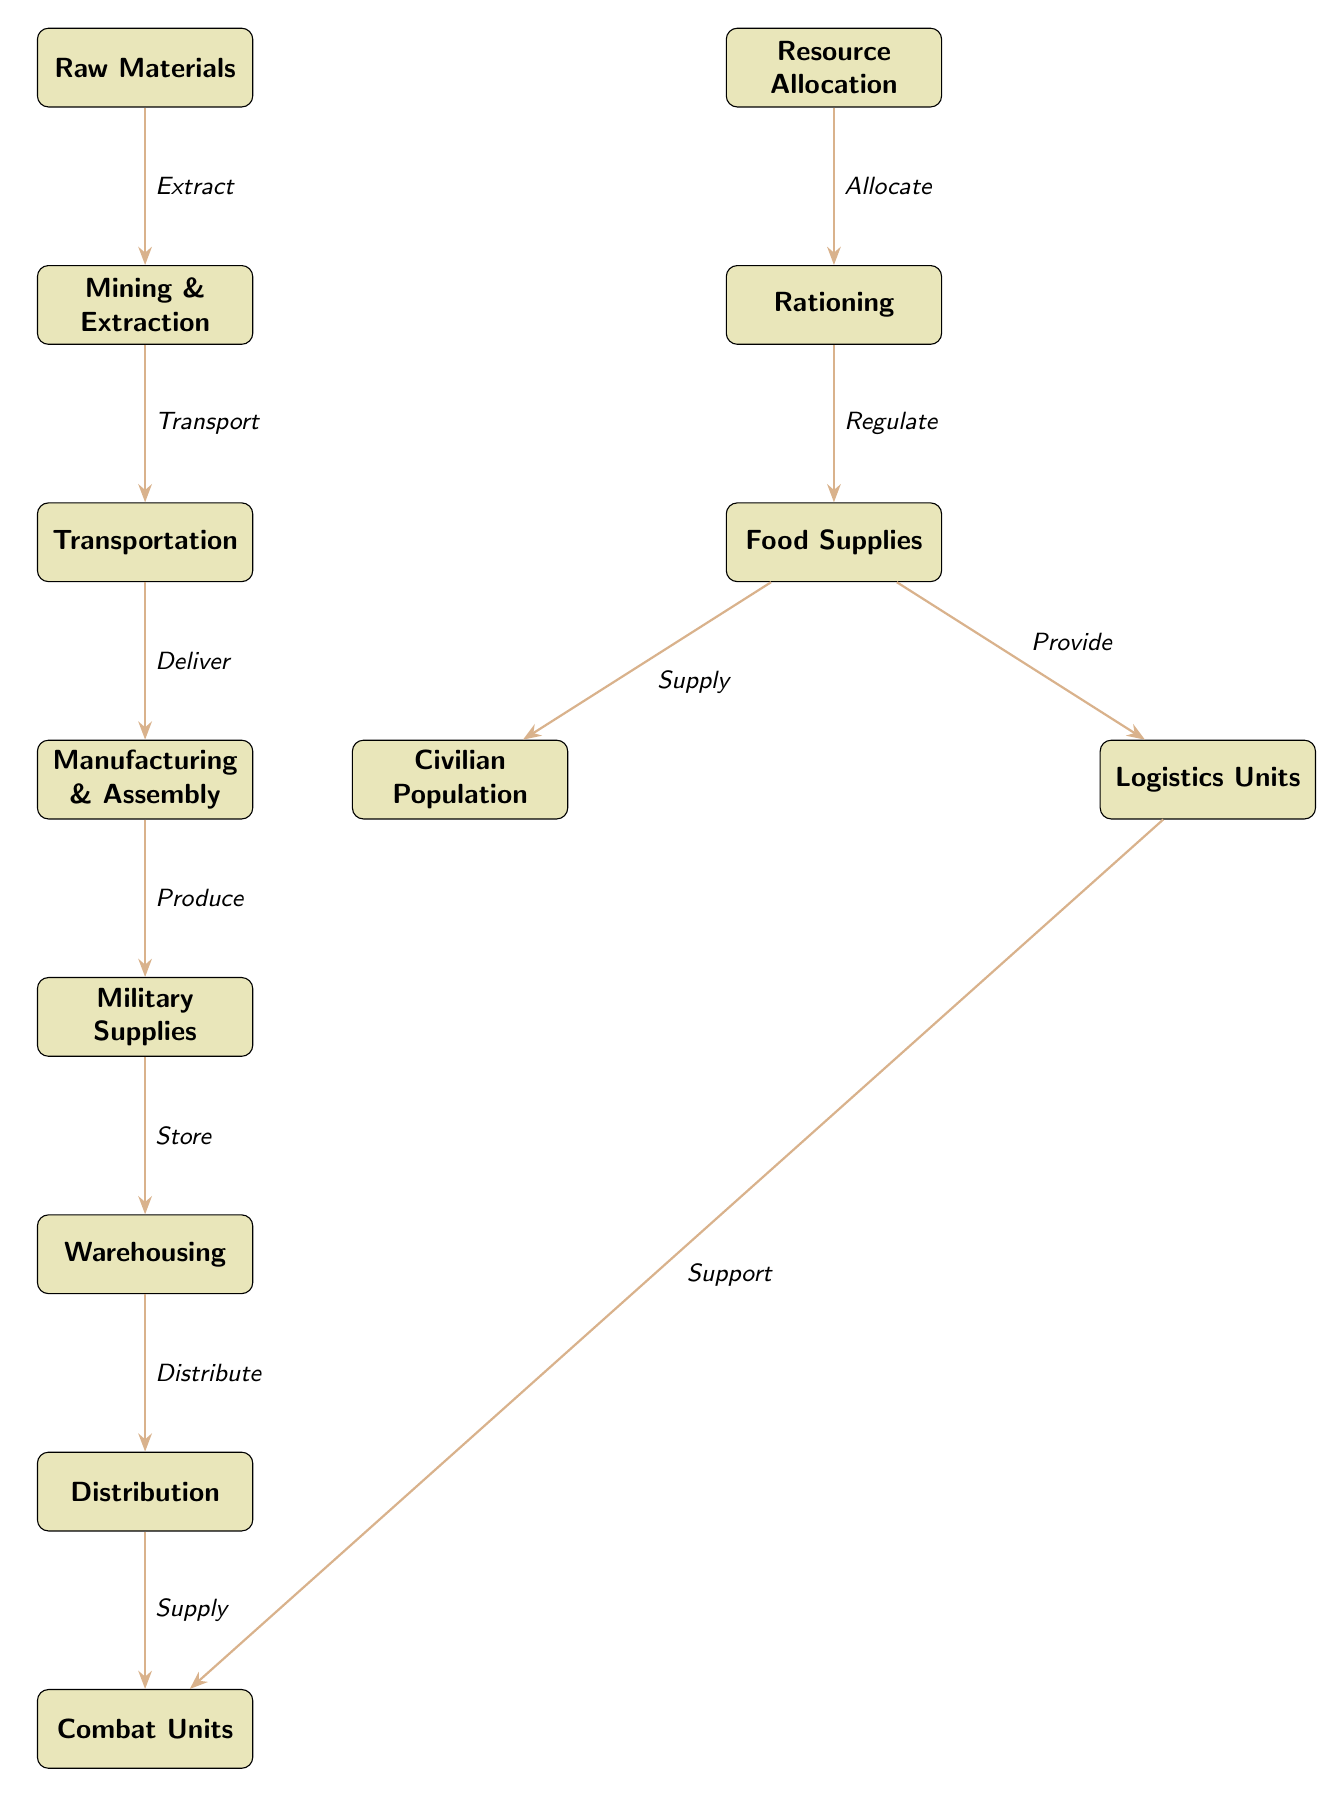What is the first step in the food chain? The first step in the food chain, depicted in the diagram, is "Raw Materials," which is the initial node from which the process starts.
Answer: Raw Materials How many nodes are there in total? By counting all the distinct nodes in the diagram, including both main and side chains, we find there are 13 nodes in total.
Answer: 13 What connects "Transportation" to "Manufacturing & Assembly"? The edge going from "Transportation" to "Manufacturing & Assembly" is labeled "Deliver," indicating the action that connects these two nodes.
Answer: Deliver Which node supplies the "Civilian Population"? The node "Food Supplies" supplies the "Civilian Population," as represented by the directed edge from "Food Supplies" to "Civilian Population."
Answer: Food Supplies What is the last step before supplies reach "Combat Units"? The last step before reaching "Combat Units" is "Distribution," which is the node that directly precedes it in the process.
Answer: Distribution How are "Logistics Units" related to "Combat Units"? "Logistics Units" provide support to "Combat Units," as indicated by the connecting edge labeled "Support" that flows from "Logistics Units" to "Combat Units."
Answer: Support What role does "Rationing" play in resource allocation? "Rationing" regulates the flow and distribution of food supplies, showing it as a critical component of resource allocation in the diagram.
Answer: Regulate Which node leads directly to "Warehousing"? The node that leads directly to "Warehousing" is "Military Supplies," with the connection indicated by the edge labeled "Store."
Answer: Military Supplies What action follows "Manufacturing & Assembly"? The action that follows "Manufacturing & Assembly" is "Produce," which is the directed connection that illustrates the transition to "Military Supplies."
Answer: Produce 